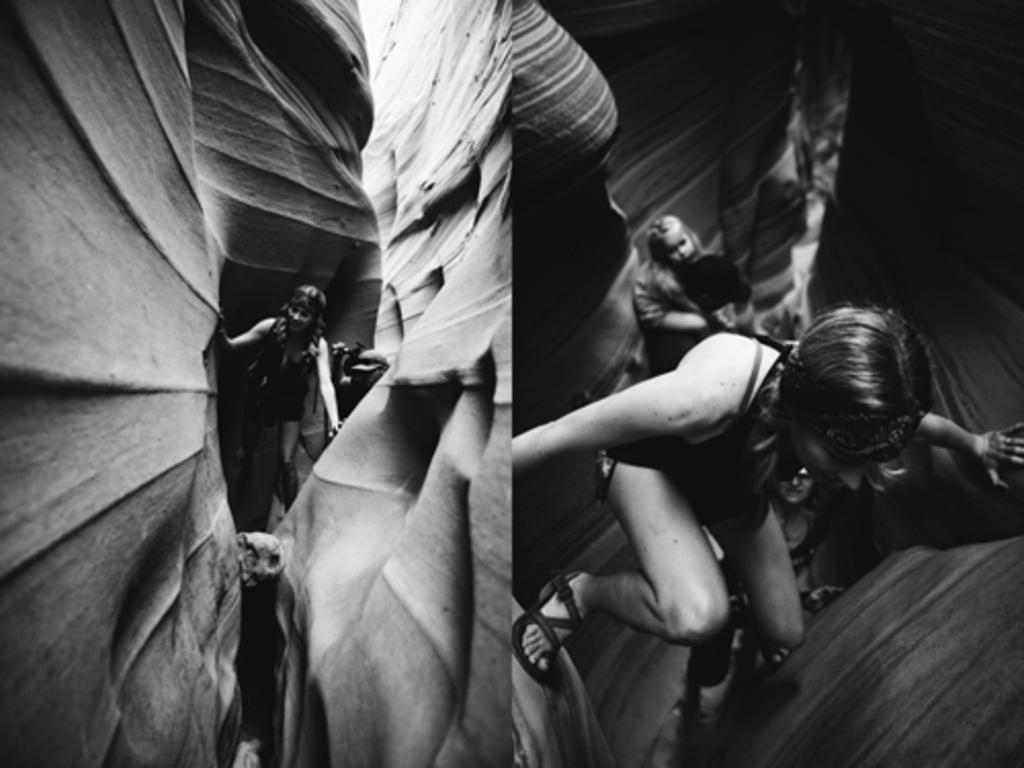What type of photos are present in the image? There are two collage photos of women in the image. What color scheme is used in the image? The image is black and white in color. How many letters are visible in the card in the image? There is no card or letters present in the image; it only contains two collage photos of women. 